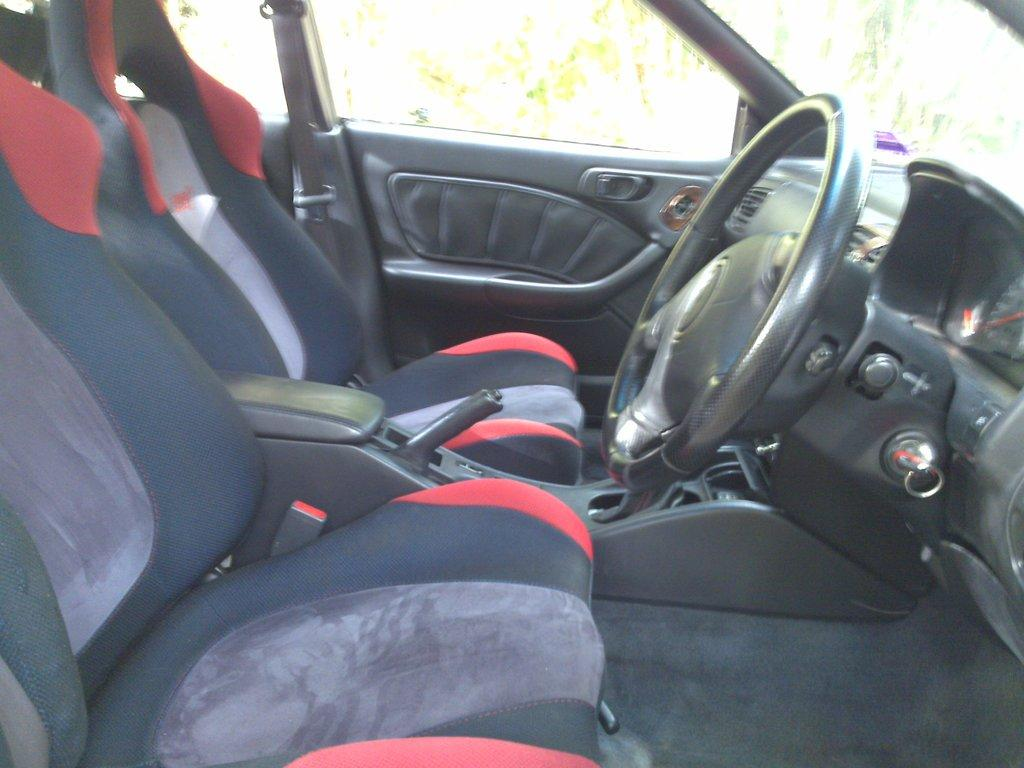What type of vehicle is shown in the image? The image shows the inside view of a car. What can be found inside the car? There are seats, a button handbrake, a gear, a steering wheel, an auto gauge, and a seat belt inside the car. Can you describe the car door in the image? There is a car door in the image. How many houses are visible in the image? There are no houses visible in the image; it shows the inside view of a car. Is there a mask being worn by the driver in the image? There is no driver or anyone wearing a mask present in the image. 